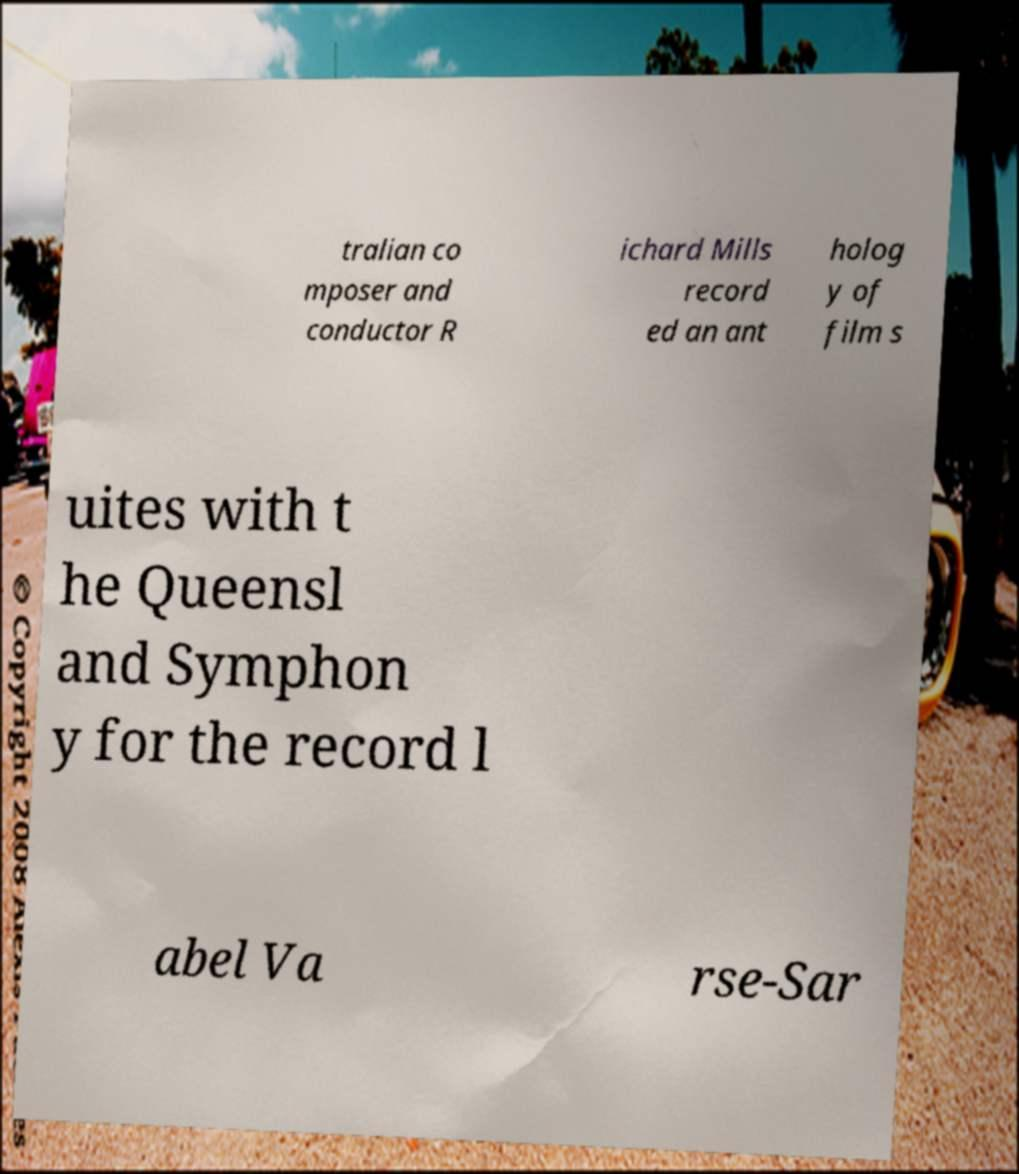For documentation purposes, I need the text within this image transcribed. Could you provide that? tralian co mposer and conductor R ichard Mills record ed an ant holog y of film s uites with t he Queensl and Symphon y for the record l abel Va rse-Sar 